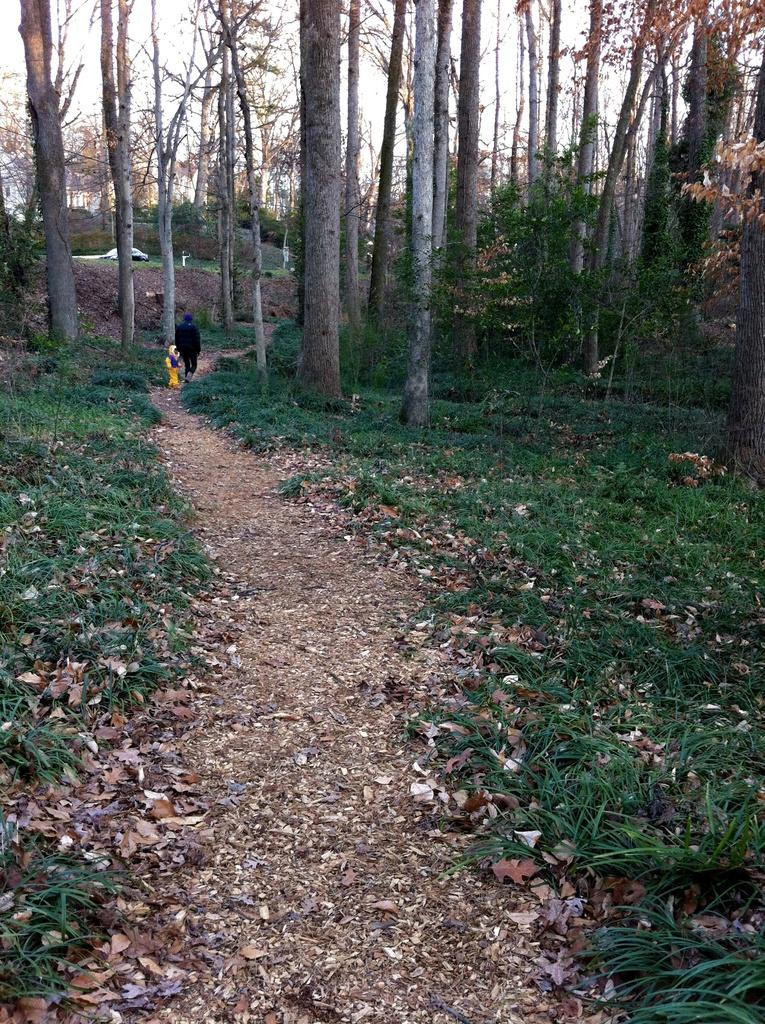What can be seen in the foreground of the image? There is a path in the foreground of the image. What type of vegetation is present alongside the path? There is grass on either side of the path. What else can be seen alongside the path? There are trees on either side of the path. What are the two people in the image doing? Two people are walking on the path. What can be seen in the background of the image? There are trees and the sky visible in the background of the image. Can you see a goat wearing a ring in the image? No, there is no goat or ring present in the image. What type of creature is shown interacting with the trees in the image? There is no creature shown interacting with the trees in the image; only the path, grass, trees, and people are present. 